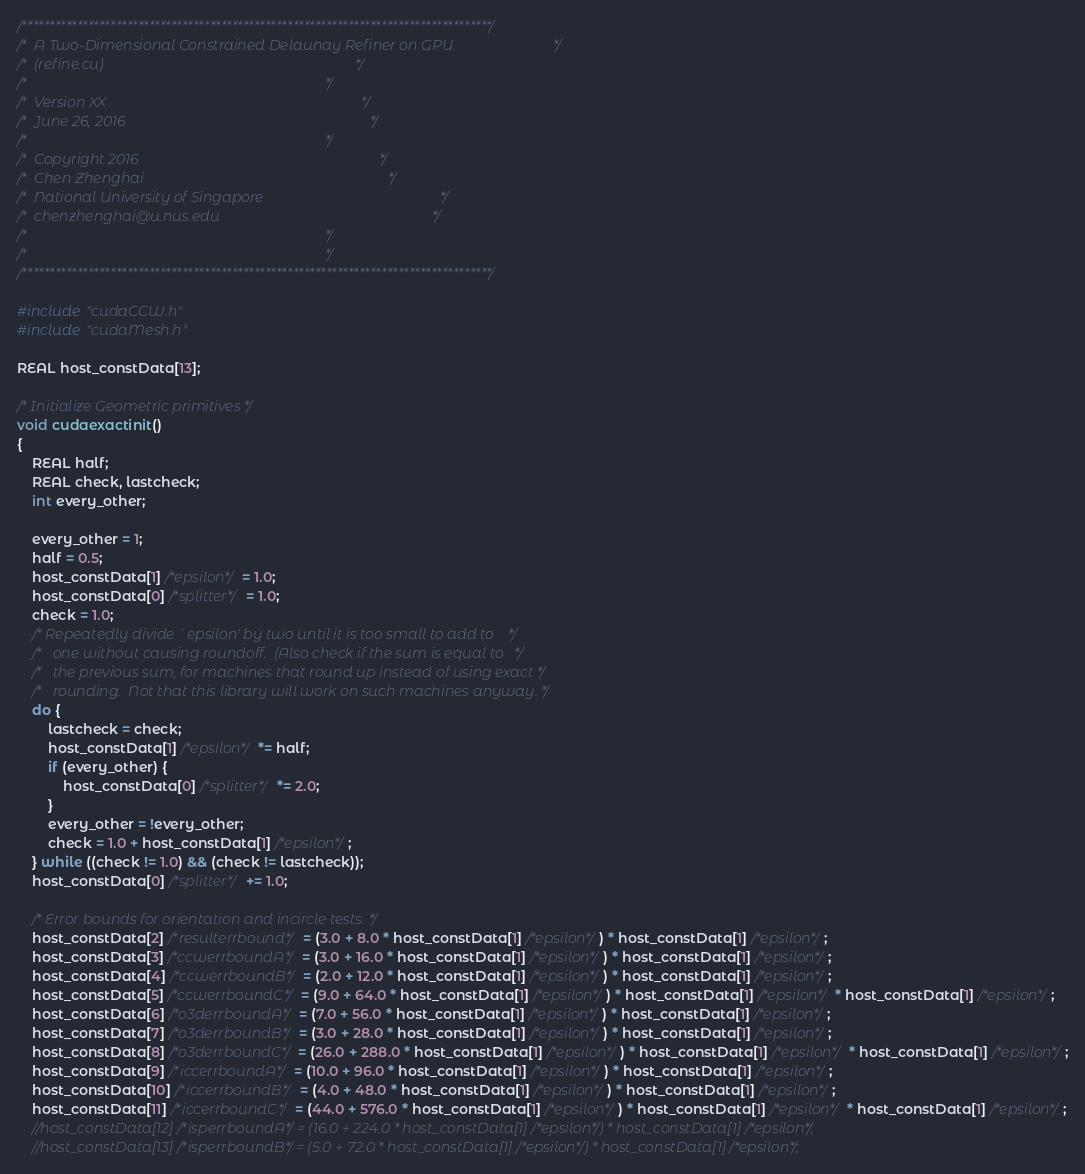<code> <loc_0><loc_0><loc_500><loc_500><_Cuda_>/*************************************************************************************/
/*  A Two-Dimensional Constrained Delaunay Refiner on GPU.							 */
/*  (refine.cu)																		 */
/*																					 */
/*  Version XX																		 */
/*  June 26, 2016																	 */
/*																					 */
/*  Copyright 2016																	 */
/*	Chen Zhenghai																	 */
/*  National University of Singapore												 */
/*  chenzhenghai@u.nus.edu															 */
/*  																				 */
/*																					 */
/*************************************************************************************/

#include "cudaCCW.h"
#include "cudaMesh.h"

REAL host_constData[13];

/* Initialize Geometric primitives */
void cudaexactinit()
{
	REAL half;
	REAL check, lastcheck;
	int every_other;

	every_other = 1;
	half = 0.5;
	host_constData[1] /*epsilon*/ = 1.0;
	host_constData[0] /*splitter*/ = 1.0;
	check = 1.0;
	/* Repeatedly divide `epsilon' by two until it is too small to add to    */
	/*   one without causing roundoff.  (Also check if the sum is equal to   */
	/*   the previous sum, for machines that round up instead of using exact */
	/*   rounding.  Not that this library will work on such machines anyway. */
	do {
		lastcheck = check;
		host_constData[1] /*epsilon*/ *= half;
		if (every_other) {
			host_constData[0] /*splitter*/ *= 2.0;
		}
		every_other = !every_other;
		check = 1.0 + host_constData[1] /*epsilon*/;
	} while ((check != 1.0) && (check != lastcheck));
	host_constData[0] /*splitter*/ += 1.0;

	/* Error bounds for orientation and incircle tests. */
	host_constData[2] /*resulterrbound*/ = (3.0 + 8.0 * host_constData[1] /*epsilon*/) * host_constData[1] /*epsilon*/;
	host_constData[3] /*ccwerrboundA*/ = (3.0 + 16.0 * host_constData[1] /*epsilon*/) * host_constData[1] /*epsilon*/;
	host_constData[4] /*ccwerrboundB*/ = (2.0 + 12.0 * host_constData[1] /*epsilon*/) * host_constData[1] /*epsilon*/;
	host_constData[5] /*ccwerrboundC*/ = (9.0 + 64.0 * host_constData[1] /*epsilon*/) * host_constData[1] /*epsilon*/ * host_constData[1] /*epsilon*/;
	host_constData[6] /*o3derrboundA*/ = (7.0 + 56.0 * host_constData[1] /*epsilon*/) * host_constData[1] /*epsilon*/;
	host_constData[7] /*o3derrboundB*/ = (3.0 + 28.0 * host_constData[1] /*epsilon*/) * host_constData[1] /*epsilon*/;
	host_constData[8] /*o3derrboundC*/ = (26.0 + 288.0 * host_constData[1] /*epsilon*/) * host_constData[1] /*epsilon*/ * host_constData[1] /*epsilon*/;
	host_constData[9] /*iccerrboundA*/ = (10.0 + 96.0 * host_constData[1] /*epsilon*/) * host_constData[1] /*epsilon*/;
	host_constData[10] /*iccerrboundB*/ = (4.0 + 48.0 * host_constData[1] /*epsilon*/) * host_constData[1] /*epsilon*/;
	host_constData[11] /*iccerrboundC*/ = (44.0 + 576.0 * host_constData[1] /*epsilon*/) * host_constData[1] /*epsilon*/ * host_constData[1] /*epsilon*/;
	//host_constData[12] /*isperrboundA*/ = (16.0 + 224.0 * host_constData[1] /*epsilon*/) * host_constData[1] /*epsilon*/;
	//host_constData[13] /*isperrboundB*/ = (5.0 + 72.0 * host_constData[1] /*epsilon*/) * host_constData[1] /*epsilon*/;</code> 